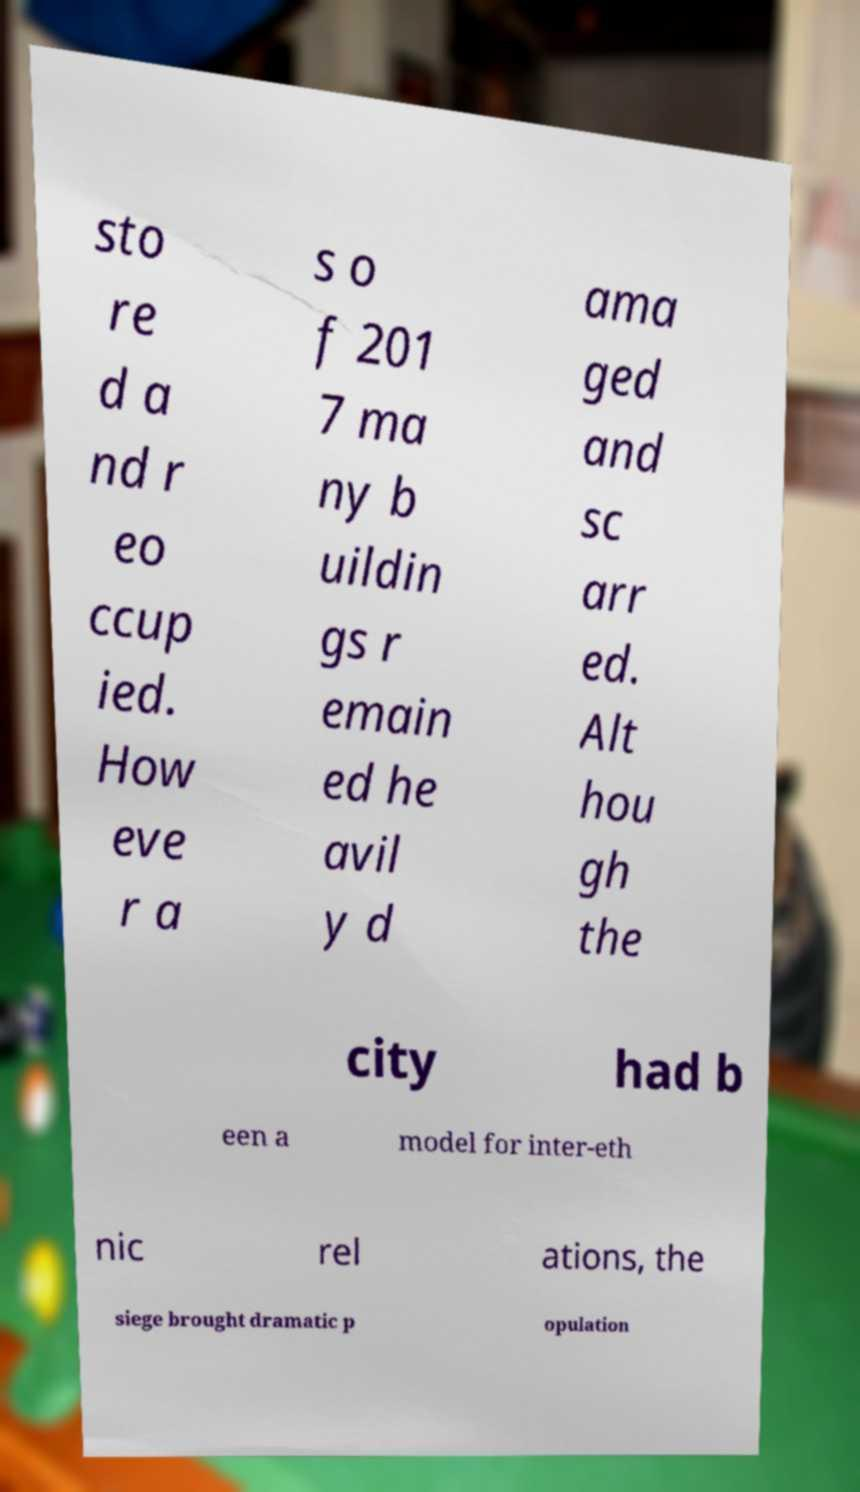There's text embedded in this image that I need extracted. Can you transcribe it verbatim? sto re d a nd r eo ccup ied. How eve r a s o f 201 7 ma ny b uildin gs r emain ed he avil y d ama ged and sc arr ed. Alt hou gh the city had b een a model for inter-eth nic rel ations, the siege brought dramatic p opulation 